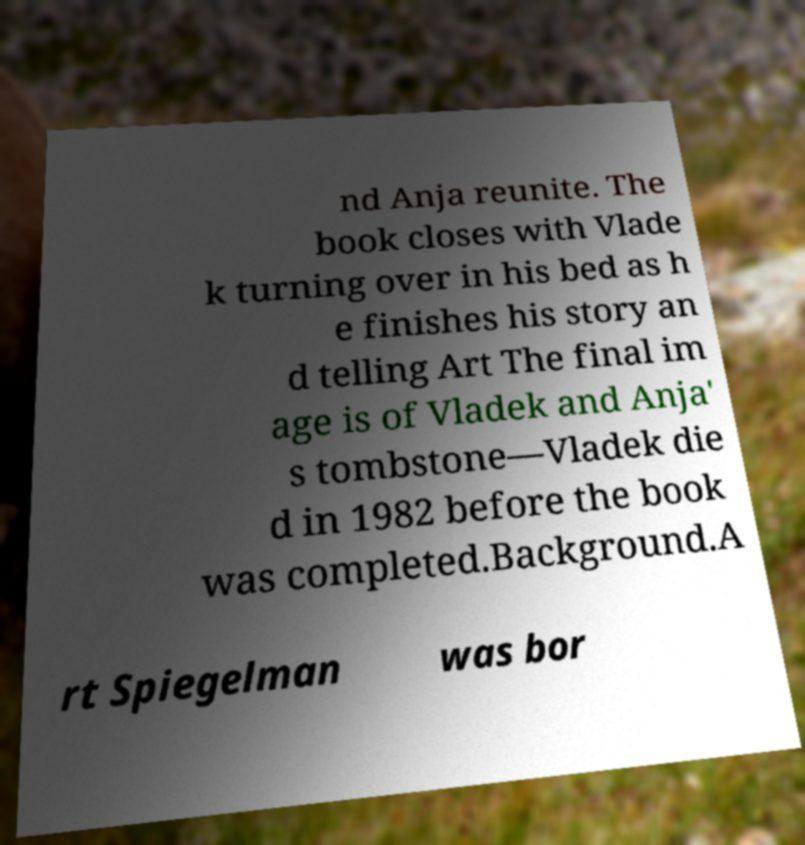I need the written content from this picture converted into text. Can you do that? nd Anja reunite. The book closes with Vlade k turning over in his bed as h e finishes his story an d telling Art The final im age is of Vladek and Anja' s tombstone—Vladek die d in 1982 before the book was completed.Background.A rt Spiegelman was bor 